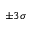Convert formula to latex. <formula><loc_0><loc_0><loc_500><loc_500>\pm 3 \sigma</formula> 